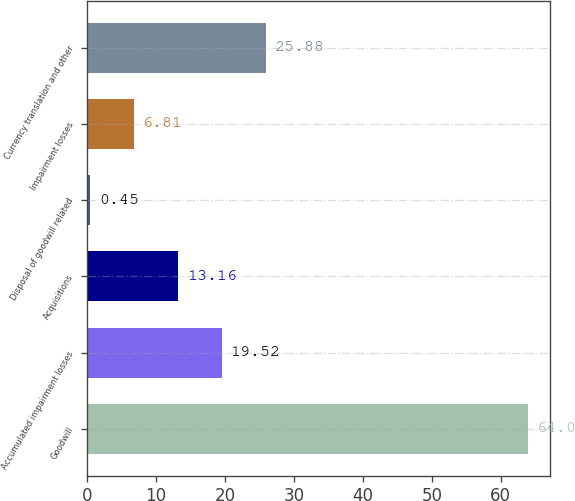Convert chart. <chart><loc_0><loc_0><loc_500><loc_500><bar_chart><fcel>Goodwill<fcel>Accumulated impairment losses<fcel>Acquisitions<fcel>Disposal of goodwill related<fcel>Impairment losses<fcel>Currency translation and other<nl><fcel>64<fcel>19.52<fcel>13.16<fcel>0.45<fcel>6.81<fcel>25.88<nl></chart> 